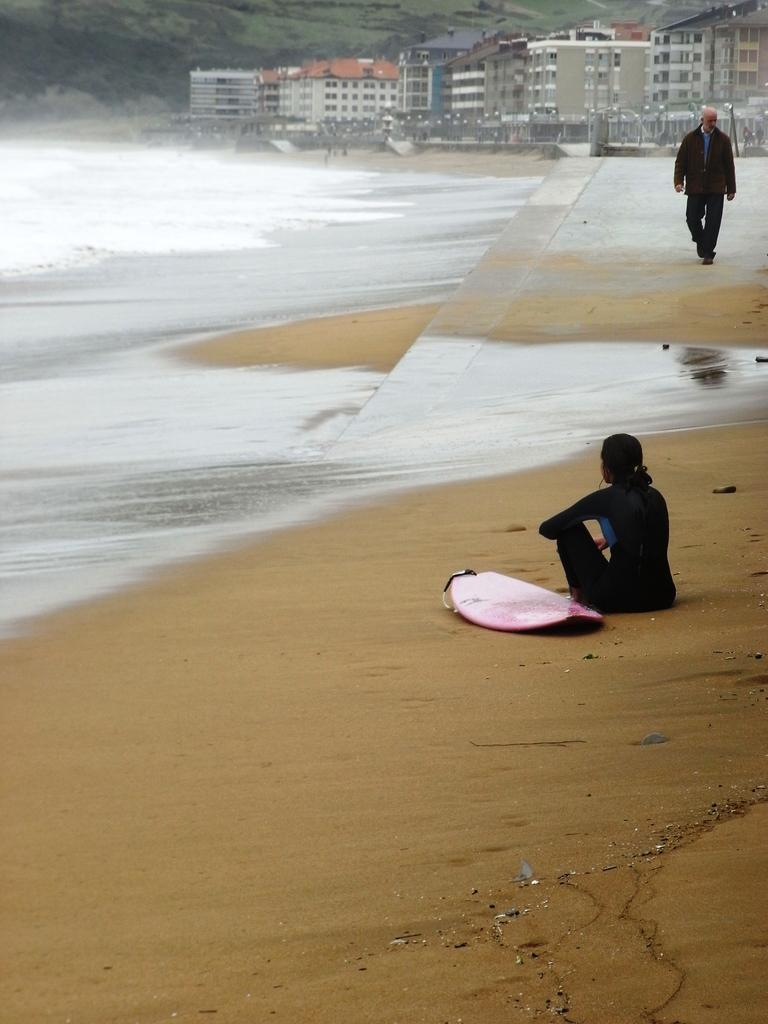How many people are present in the image? There are two persons in the image. Where is the image taken? The image is taken on a beach. What can be seen in the background of the image? There is water, a fence, buildings, trees, and mountains visible in the background. What type of root can be seen growing in the office in the image? There is no office or root present in the image; it is taken on a beach with various natural elements in the background. 